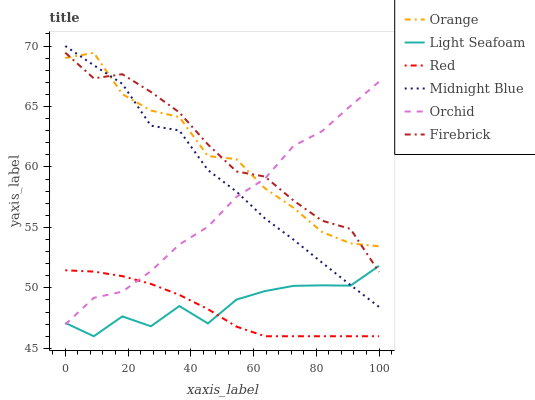Does Red have the minimum area under the curve?
Answer yes or no. Yes. Does Firebrick have the maximum area under the curve?
Answer yes or no. Yes. Does Orange have the minimum area under the curve?
Answer yes or no. No. Does Orange have the maximum area under the curve?
Answer yes or no. No. Is Red the smoothest?
Answer yes or no. Yes. Is Light Seafoam the roughest?
Answer yes or no. Yes. Is Firebrick the smoothest?
Answer yes or no. No. Is Firebrick the roughest?
Answer yes or no. No. Does Light Seafoam have the lowest value?
Answer yes or no. Yes. Does Firebrick have the lowest value?
Answer yes or no. No. Does Midnight Blue have the highest value?
Answer yes or no. Yes. Does Firebrick have the highest value?
Answer yes or no. No. Is Red less than Midnight Blue?
Answer yes or no. Yes. Is Firebrick greater than Red?
Answer yes or no. Yes. Does Light Seafoam intersect Midnight Blue?
Answer yes or no. Yes. Is Light Seafoam less than Midnight Blue?
Answer yes or no. No. Is Light Seafoam greater than Midnight Blue?
Answer yes or no. No. Does Red intersect Midnight Blue?
Answer yes or no. No. 